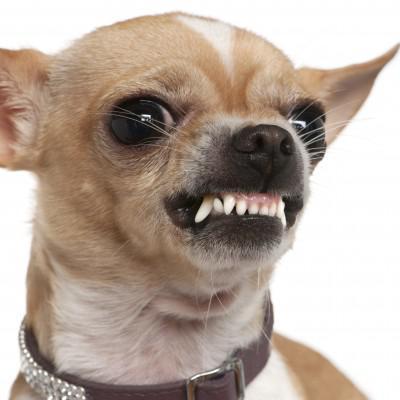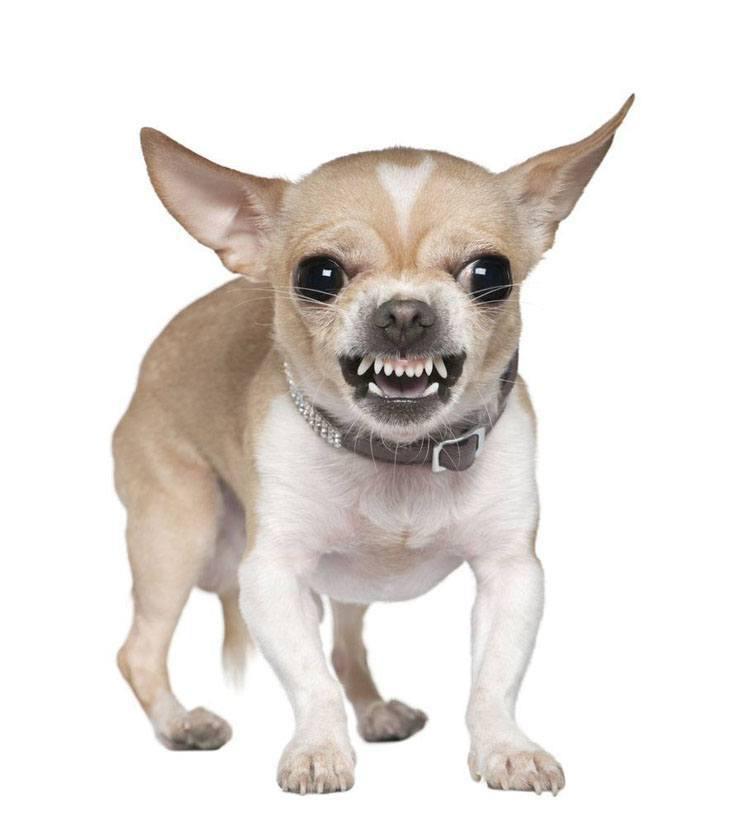The first image is the image on the left, the second image is the image on the right. Evaluate the accuracy of this statement regarding the images: "In at least one image, the dog's teeth are not bared.". Is it true? Answer yes or no. No. 